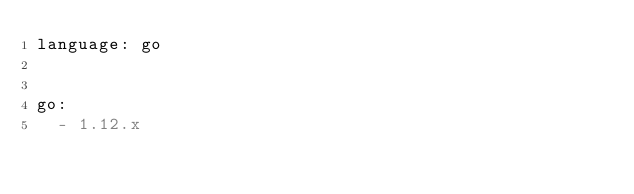Convert code to text. <code><loc_0><loc_0><loc_500><loc_500><_YAML_>language: go


go:
  - 1.12.x
</code> 